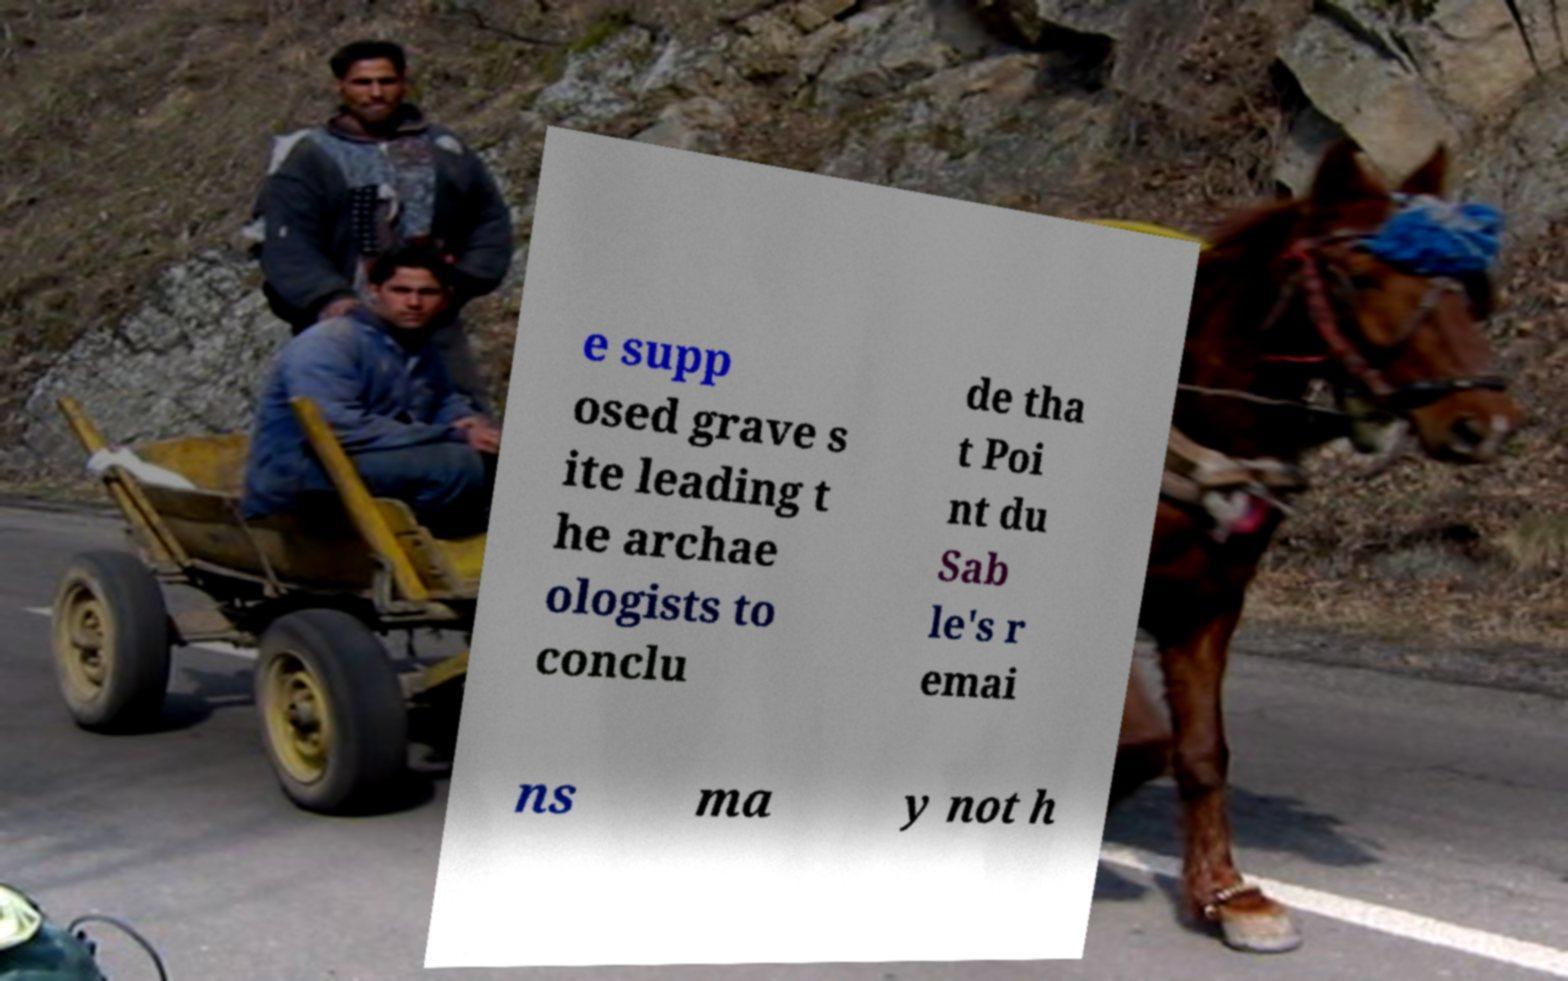I need the written content from this picture converted into text. Can you do that? e supp osed grave s ite leading t he archae ologists to conclu de tha t Poi nt du Sab le's r emai ns ma y not h 